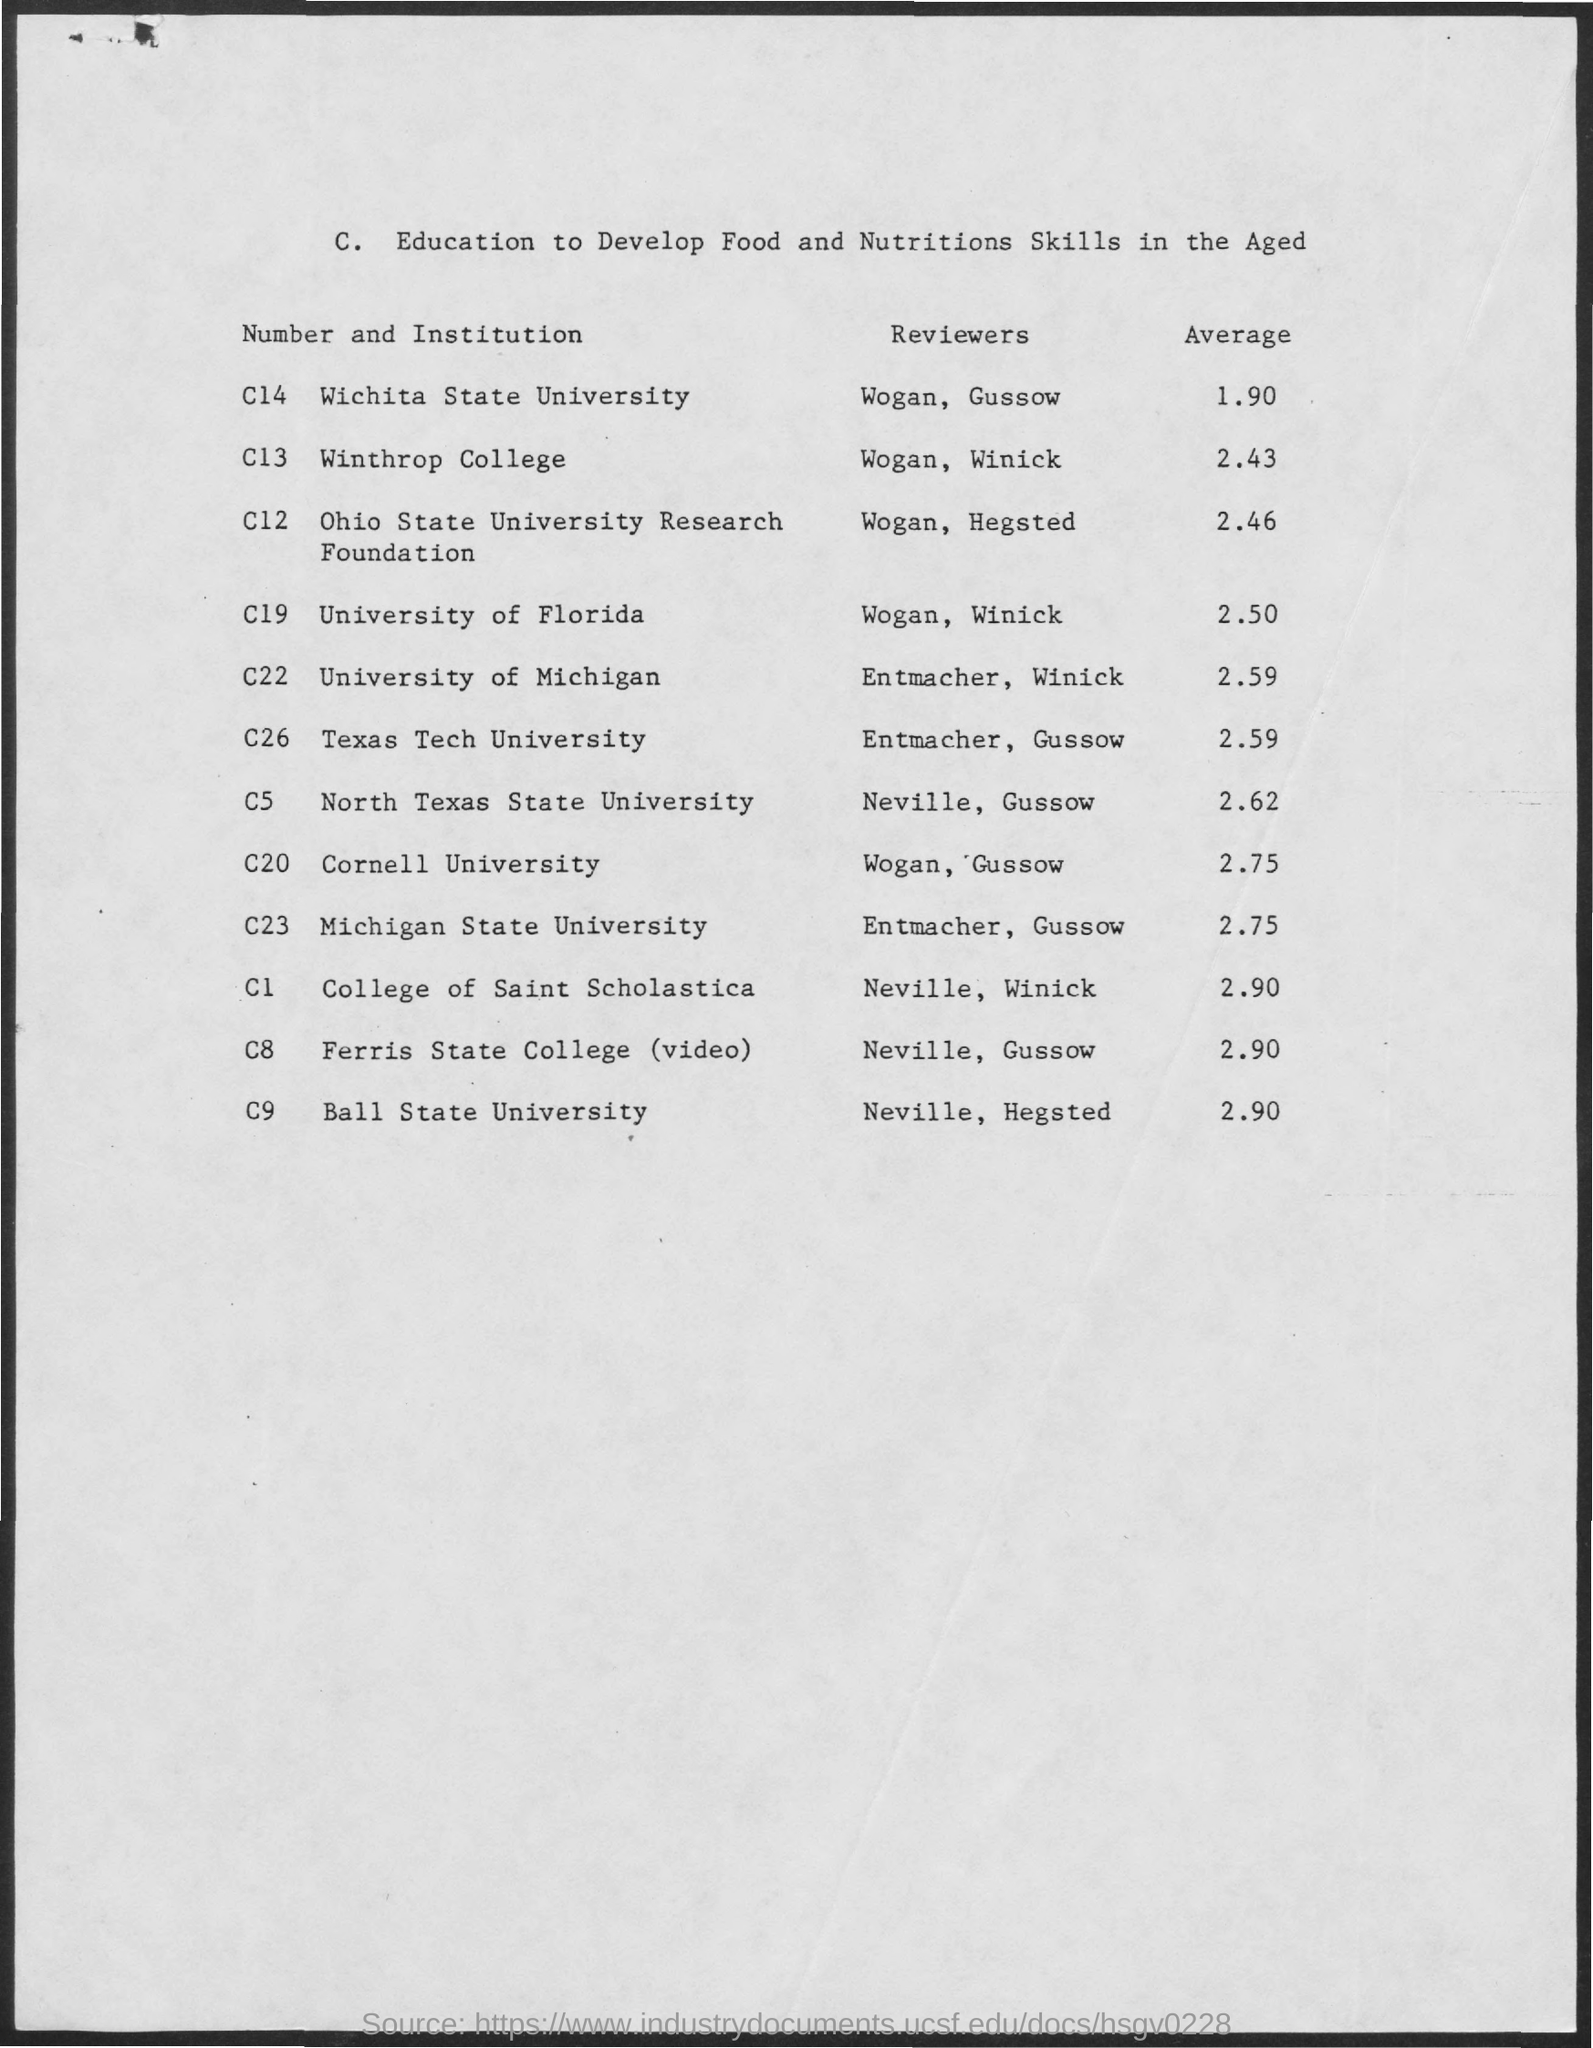What is the Average for Wichita State University?
Offer a very short reply. 1.90. What is the Average for Winthrop College?
Your response must be concise. 2.43. What is the Average for University of Florida?
Your answer should be compact. 2.50. What is the Average for University of Michigan?
Offer a terse response. 2.59. What is the Average for Texas Tech University?
Offer a very short reply. 2.59. What is the Average for North Texas State University?
Ensure brevity in your answer.  2.62. What is the Average for Cornell University?
Your answer should be compact. 2.75. What is the Average for Michigan State University?
Offer a terse response. 2.75. What is the Average for Ball State University?
Give a very brief answer. 2.90. What is the Average for College of Saint Scholastica?
Provide a succinct answer. 2.90. 